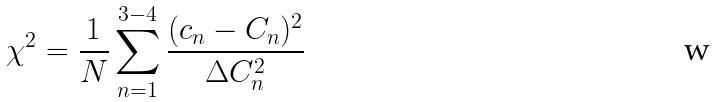Convert formula to latex. <formula><loc_0><loc_0><loc_500><loc_500>\chi ^ { 2 } = \frac { 1 } { N } \sum _ { n = 1 } ^ { 3 - 4 } { \frac { ( c _ { n } - C _ { n } ) ^ { 2 } } { \Delta C _ { n } ^ { 2 } } }</formula> 